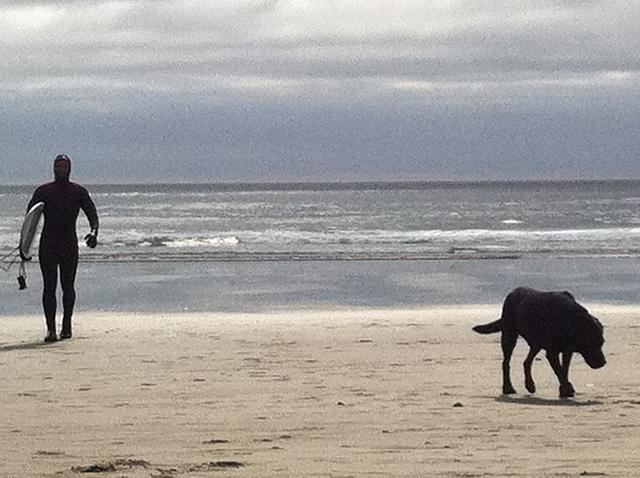Who owns this dog?

Choices:
A) hippies
B) vagabond
C) police
D) surfer surfer 